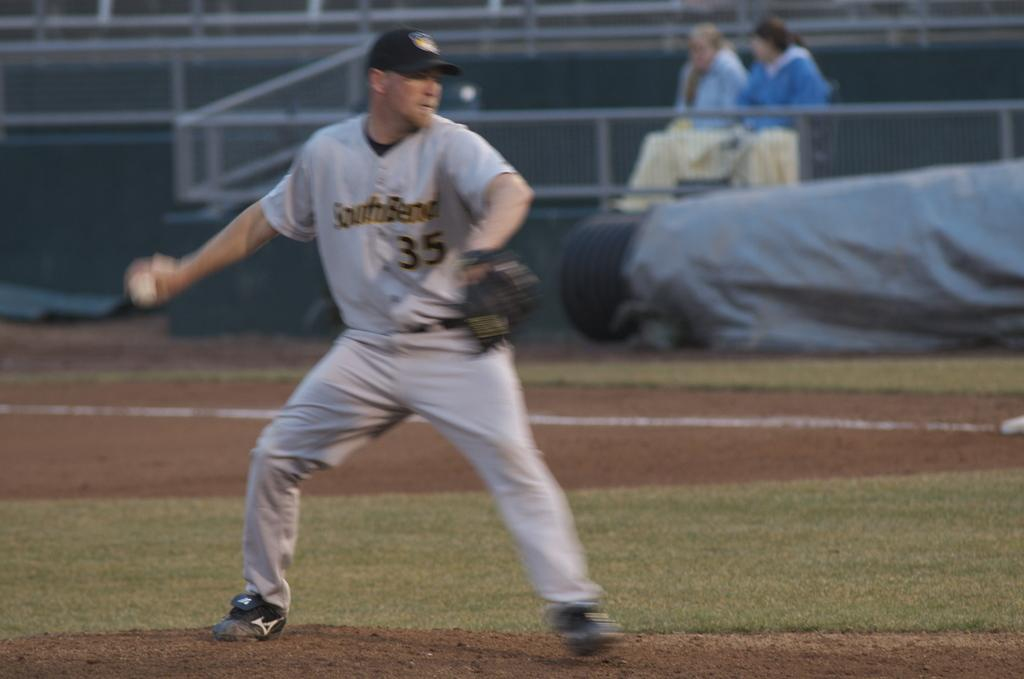<image>
Render a clear and concise summary of the photo. A player for the South Bend baseball team wears number 35. 